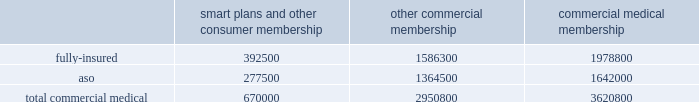Va health care delivery system through our network of providers .
We are compensated by the va for the cost of our providers 2019 services at a specified contractual amount per service plus an additional administrative fee for each transaction .
The contract , under which we began providing services on january 1 , 2008 , is comprised of one base period and four one-year option periods subject to renewals at the federal government 2019s option .
We are currently in the first option period , which expires on september 30 , 2009 .
For the year ended december 31 , 2008 , revenues under this va contract were approximately $ 22.7 million , or less than 1% ( 1 % ) of our total premium and aso fees .
For the year ended december 31 , 2008 , military services premium revenues were approximately $ 3.2 billion , or 11.3% ( 11.3 % ) of our total premiums and aso fees , and military services aso fees totaled $ 76.8 million , or 0.3% ( 0.3 % ) of our total premiums and aso fees .
International and green ribbon health operations in august 2006 , we established our subsidiary humana europe in the united kingdom to provide commissioning support to primary care trusts , or pcts , in england .
Under the contracts we are awarded , we work in partnership with local pcts , health care providers , and patients to strengthen health-service delivery and to implement strategies at a local level to help the national health service enhance patient experience , improve clinical outcomes , and reduce costs .
For the year ended december 31 , 2008 , revenues under these contracts were approximately $ 7.7 million , or less than 1% ( 1 % ) of our total premium and aso fees .
We participated in a medicare health support pilot program through green ribbon health , or grh , a joint- venture company with pfizer health solutions inc .
Grh was designed to support cms assigned medicare beneficiaries living with diabetes and/or congestive heart failure in central florida .
Grh used disease management initiatives , including evidence-based clinical guidelines , personal self-directed change strategies , and personal nurses to help participants navigate the health system .
Revenues under the contract with cms over the period which began november 1 , 2005 and ended august 15 , 2008 are subject to refund unless savings , satisfaction , and clinical improvement targets are met .
Under the terms of the contract , after a claims run-out period , cms is required to deliver a performance report during the third quarter of 2009 .
To date , all revenues have been deferred until reliable estimates are determinable , and revenues are not expected to be material when recognized .
Our products marketed to commercial segment employers and members smart plans and other consumer products over the last several years , we have developed and offered various commercial products designed to provide options and choices to employers that are annually facing substantial premium increases driven by double-digit medical cost inflation .
These smart plans , discussed more fully below , and other consumer offerings , which can be offered on either a fully-insured or aso basis , provided coverage to approximately 670000 members at december 31 , 2008 , representing approximately 18.5% ( 18.5 % ) of our total commercial medical membership as detailed below .
Smart plans and other consumer membership other commercial membership commercial medical membership .
These products are often offered to employer groups as 201cbundles 201d , where the subscribers are offered various hmo and ppo options , with various employer contribution strategies as determined by the employer. .
At december 31 , 2008 what was the total number of commercial medical membership 3621621.62? 
Rationale: at december 31 , 2008 the approximate number of the total commercial medical membership was 3621621.62
Computations: (670000 / 18.5%)
Answer: 3621621.62162. 